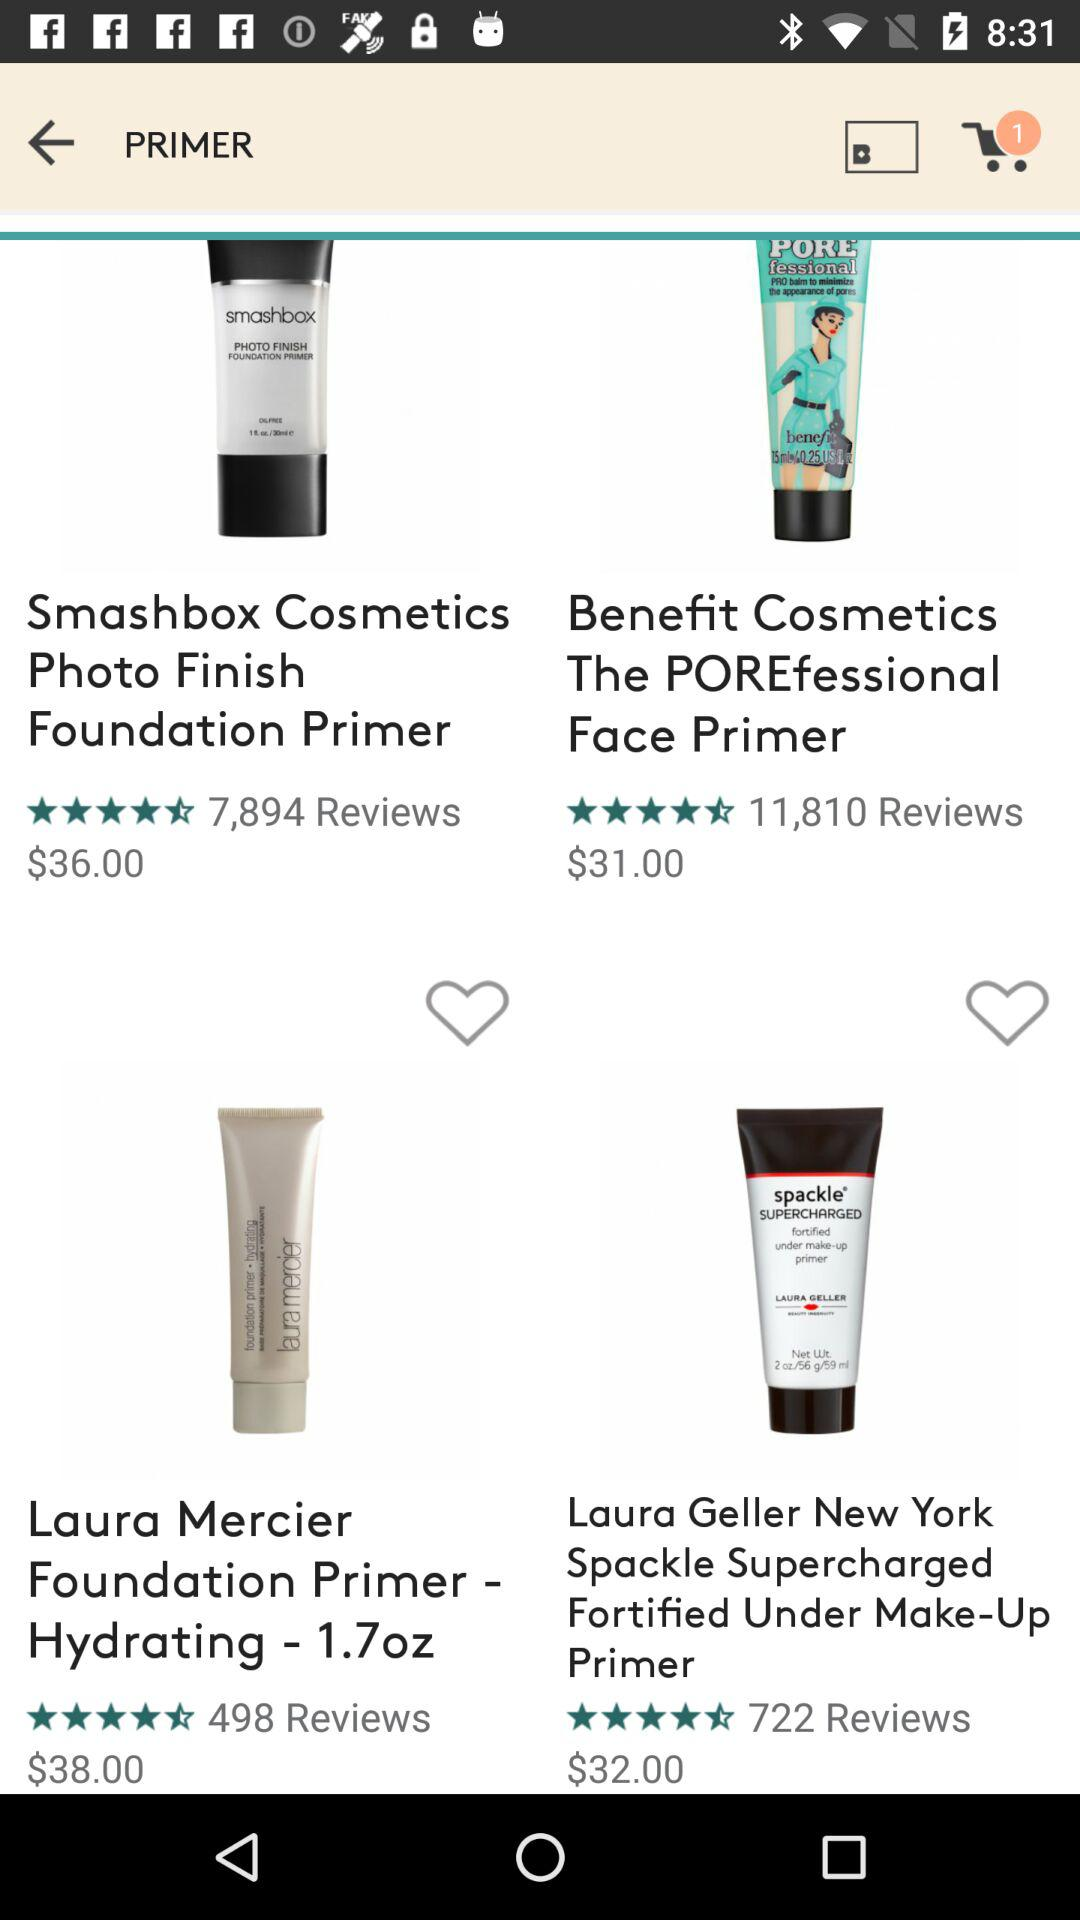What's the cost of "Benefits Cosmetics The POREfessional Face Primer"?
Answer the question using a single word or phrase. The cost is $31.00 